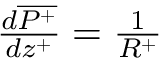Convert formula to latex. <formula><loc_0><loc_0><loc_500><loc_500>\begin{array} { r } { \frac { d \overline { { P ^ { + } } } } { d z ^ { + } } = { \frac { 1 } { R ^ { + } } } } \end{array}</formula> 